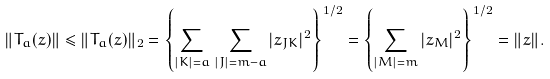<formula> <loc_0><loc_0><loc_500><loc_500>\| T _ { a } ( z ) \| \leq \| T _ { a } ( z ) \| _ { 2 } = \left \{ \sum _ { | K | = a } \, \sum _ { | J | = m - a } | z _ { J K } | ^ { 2 } \right \} ^ { 1 / 2 } = \left \{ \sum _ { | M | = m } | z _ { M } | ^ { 2 } \right \} ^ { 1 / 2 } = \| z \| .</formula> 